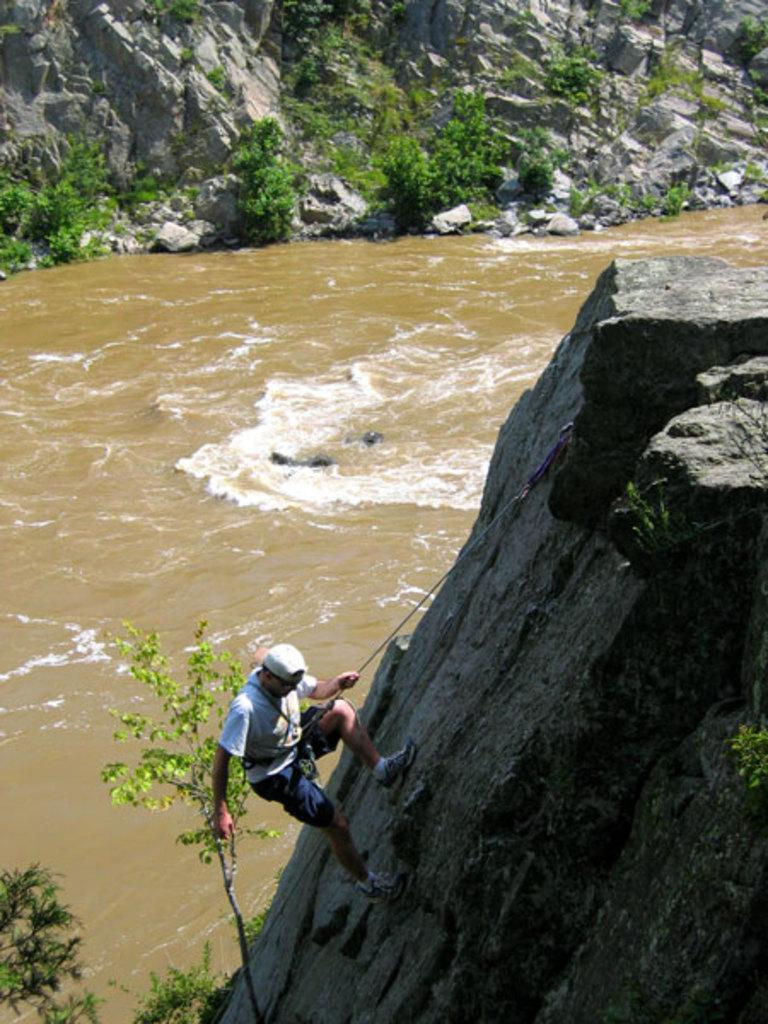What is the main subject of the image? The main subject of the image is a man. What is the man doing in the image? The man is climbing a hill in the image. What natural feature can be seen in the image? There is a river in the image. What type of vegetation is present in the image? There are plants in the image. What type of development can be seen in the image? There is no development project visible in the image; it features a man climbing a hill, a river, and plants. Can you tell me how many bridges are present in the image? There are no bridges visible in the image. What type of lamp is illuminating the area in the image? There is no lamp present in the image. 